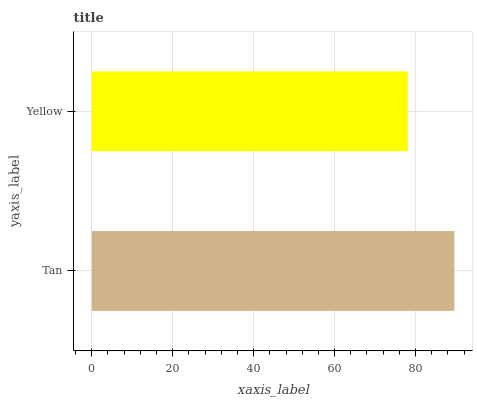Is Yellow the minimum?
Answer yes or no. Yes. Is Tan the maximum?
Answer yes or no. Yes. Is Yellow the maximum?
Answer yes or no. No. Is Tan greater than Yellow?
Answer yes or no. Yes. Is Yellow less than Tan?
Answer yes or no. Yes. Is Yellow greater than Tan?
Answer yes or no. No. Is Tan less than Yellow?
Answer yes or no. No. Is Tan the high median?
Answer yes or no. Yes. Is Yellow the low median?
Answer yes or no. Yes. Is Yellow the high median?
Answer yes or no. No. Is Tan the low median?
Answer yes or no. No. 